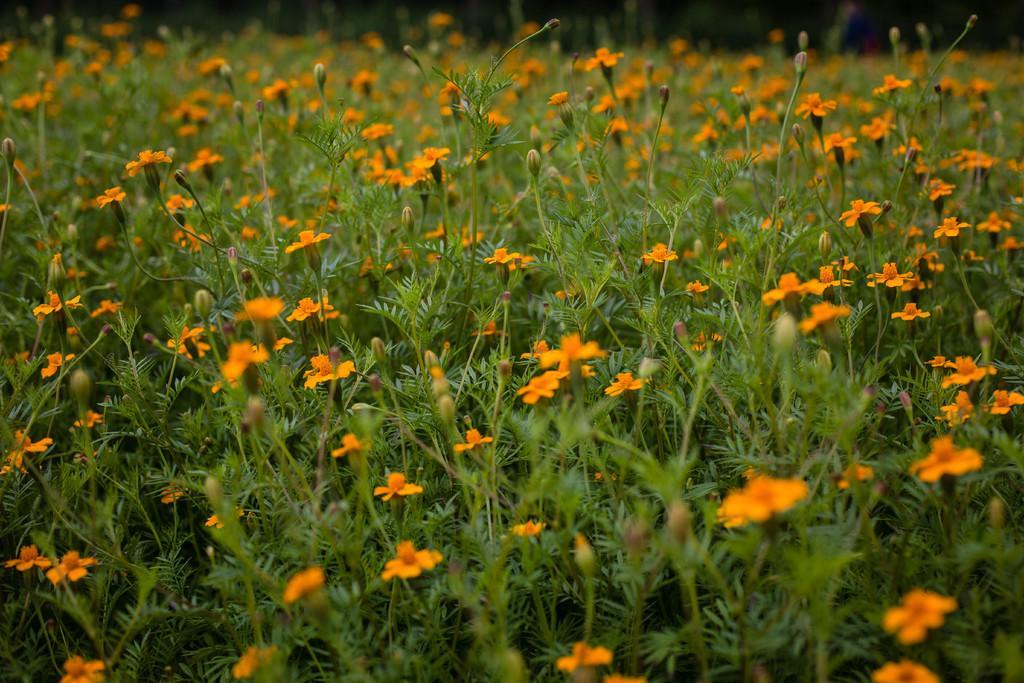How would you summarize this image in a sentence or two? In this image at the bottom there are some plants and some flowers. 